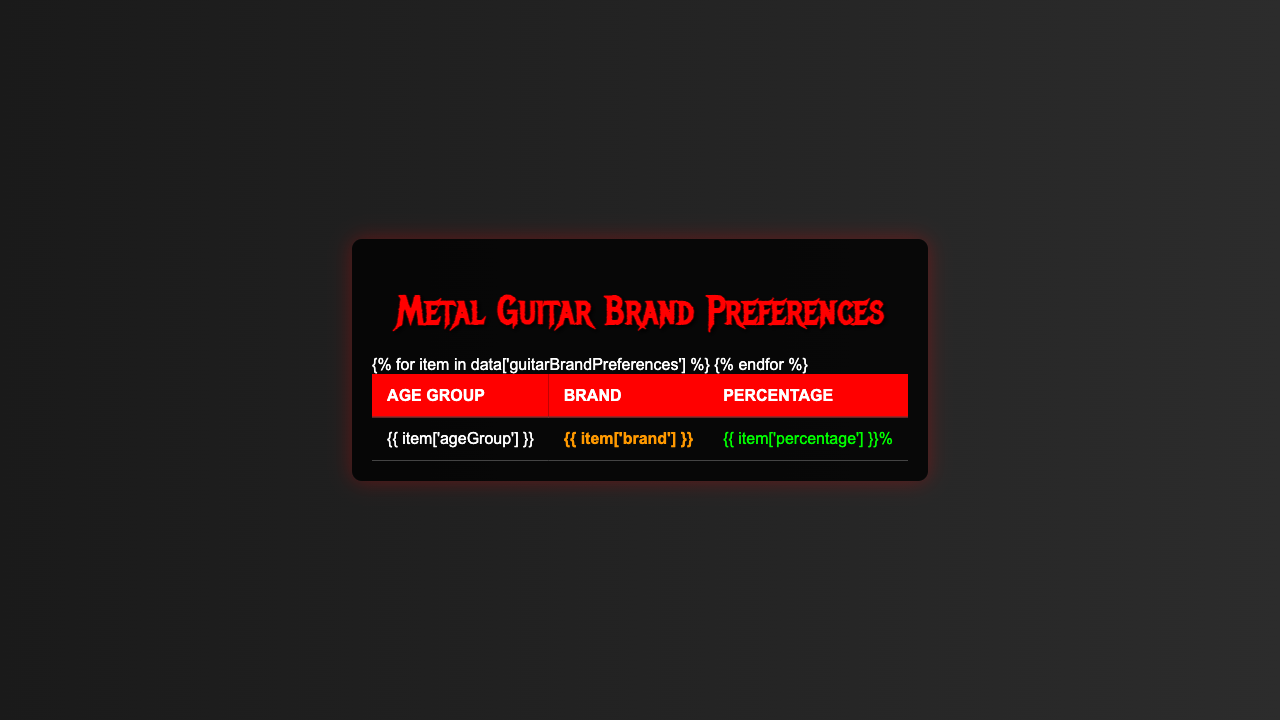What is the most preferred guitar brand among the 18-24 age group? The brand with the highest percentage in the 18-24 age group is ESP, with a percentage of 28.5%.
Answer: ESP Which guitar brand is preferred the least among the 45-54 age group? In the 45-54 age group, Fender has the lowest preference at 18.9%.
Answer: Fender What is the percentage difference between Gibson and ESP for the 35-44 age group? Gibson is preferred at 22.7% and ESP at 23.9%. The difference is 23.9% - 22.7% = 1.2%.
Answer: 1.2% Is Jackson more popular than Ibanez in the 18-24 age group? Jackson has a percentage of 22.3% while Ibanez has 19.7%, so Jackson is indeed more popular.
Answer: Yes Which age group shows the highest percentage for Gibson? The 55+ age group shows the highest percentage for Gibson at 29.8%.
Answer: 55+ What is the average percentage of ESP preference across all age groups? The percentages for ESP are 28.5, 21.8, 23.9, 20.1, and 15.2. Summing these gives 28.5 + 21.8 + 23.9 + 20.1 + 15.2 = 109.5. There are 5 data points, so the average is 109.5 / 5 = 21.9%.
Answer: 21.9% True or False: Fender is the most popular brand across all age groups. By examining the table, Fender does not have the highest percentage in any age group, with the maximum being 18.9%.
Answer: False What is the least preferred brand among the 55+ age group? In the 55+ age group, ESP has the least preference at 15.2%.
Answer: ESP For the 25-34 age group, what is the combined percentage for Gibson and Schecter? Gibson has 24.1% and Schecter has 18.6%, so combined they equal 24.1% + 18.6% = 42.7%.
Answer: 42.7% Which guitar brand has an increasing trend from age 18-24 to 55+? ESP shows an increase in preference from 28.5% in 18-24 to 20.1% in 45-54, and decreases in 55+. The trend is not increasing. No brand shows an increasing trend overall.
Answer: No 